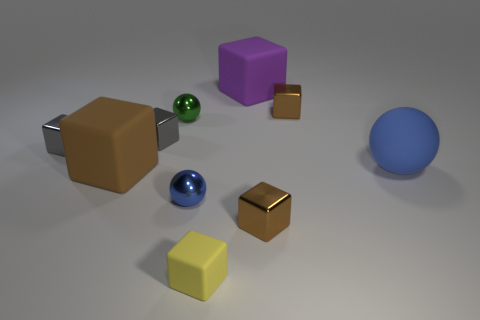What material is the small green thing?
Give a very brief answer. Metal. Is the brown thing that is on the left side of the small yellow matte cube made of the same material as the green thing?
Ensure brevity in your answer.  No. Is the yellow matte object the same size as the green object?
Your answer should be very brief. Yes. Is the number of small shiny blocks that are left of the tiny yellow rubber cube the same as the number of purple matte cubes that are on the right side of the large brown object?
Ensure brevity in your answer.  No. There is a matte thing behind the tiny sphere that is behind the large blue thing; what is its shape?
Your answer should be compact. Cube. What material is the large blue thing that is the same shape as the tiny blue shiny thing?
Your answer should be compact. Rubber. The matte ball that is the same size as the brown rubber thing is what color?
Your response must be concise. Blue. Is the number of big objects that are in front of the blue matte thing the same as the number of small matte objects?
Keep it short and to the point. Yes. What color is the large cube that is to the left of the large rubber cube to the right of the big brown block?
Provide a short and direct response. Brown. There is a object that is right of the brown cube that is behind the green shiny sphere; what size is it?
Your answer should be very brief. Large. 